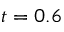<formula> <loc_0><loc_0><loc_500><loc_500>t = 0 . 6</formula> 